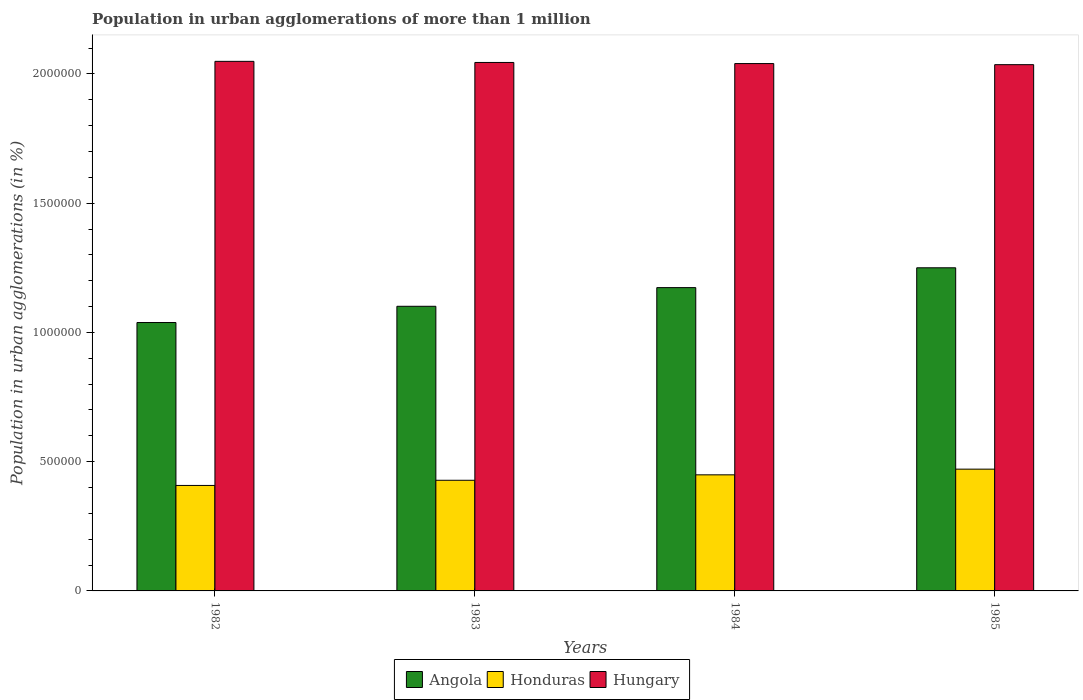How many different coloured bars are there?
Keep it short and to the point. 3. How many groups of bars are there?
Your answer should be very brief. 4. How many bars are there on the 4th tick from the left?
Offer a terse response. 3. How many bars are there on the 1st tick from the right?
Offer a terse response. 3. What is the label of the 3rd group of bars from the left?
Your answer should be very brief. 1984. In how many cases, is the number of bars for a given year not equal to the number of legend labels?
Provide a short and direct response. 0. What is the population in urban agglomerations in Hungary in 1983?
Ensure brevity in your answer.  2.04e+06. Across all years, what is the maximum population in urban agglomerations in Angola?
Provide a succinct answer. 1.25e+06. Across all years, what is the minimum population in urban agglomerations in Angola?
Offer a very short reply. 1.04e+06. In which year was the population in urban agglomerations in Angola maximum?
Provide a short and direct response. 1985. What is the total population in urban agglomerations in Honduras in the graph?
Provide a short and direct response. 1.76e+06. What is the difference between the population in urban agglomerations in Hungary in 1983 and that in 1984?
Offer a terse response. 4282. What is the difference between the population in urban agglomerations in Honduras in 1983 and the population in urban agglomerations in Angola in 1984?
Your answer should be compact. -7.45e+05. What is the average population in urban agglomerations in Angola per year?
Your response must be concise. 1.14e+06. In the year 1982, what is the difference between the population in urban agglomerations in Hungary and population in urban agglomerations in Honduras?
Your response must be concise. 1.64e+06. What is the ratio of the population in urban agglomerations in Hungary in 1983 to that in 1985?
Your answer should be very brief. 1. Is the difference between the population in urban agglomerations in Hungary in 1982 and 1984 greater than the difference between the population in urban agglomerations in Honduras in 1982 and 1984?
Keep it short and to the point. Yes. What is the difference between the highest and the second highest population in urban agglomerations in Hungary?
Your answer should be very brief. 4284. What is the difference between the highest and the lowest population in urban agglomerations in Honduras?
Make the answer very short. 6.31e+04. Is the sum of the population in urban agglomerations in Honduras in 1982 and 1984 greater than the maximum population in urban agglomerations in Angola across all years?
Give a very brief answer. No. What does the 2nd bar from the left in 1985 represents?
Provide a succinct answer. Honduras. What does the 2nd bar from the right in 1984 represents?
Provide a short and direct response. Honduras. Is it the case that in every year, the sum of the population in urban agglomerations in Hungary and population in urban agglomerations in Honduras is greater than the population in urban agglomerations in Angola?
Provide a short and direct response. Yes. How many bars are there?
Provide a short and direct response. 12. How many years are there in the graph?
Your response must be concise. 4. What is the difference between two consecutive major ticks on the Y-axis?
Offer a terse response. 5.00e+05. Are the values on the major ticks of Y-axis written in scientific E-notation?
Provide a succinct answer. No. Does the graph contain any zero values?
Offer a terse response. No. What is the title of the graph?
Provide a succinct answer. Population in urban agglomerations of more than 1 million. Does "Nigeria" appear as one of the legend labels in the graph?
Provide a succinct answer. No. What is the label or title of the Y-axis?
Offer a very short reply. Population in urban agglomerations (in %). What is the Population in urban agglomerations (in %) of Angola in 1982?
Your answer should be very brief. 1.04e+06. What is the Population in urban agglomerations (in %) of Honduras in 1982?
Your answer should be compact. 4.08e+05. What is the Population in urban agglomerations (in %) in Hungary in 1982?
Keep it short and to the point. 2.05e+06. What is the Population in urban agglomerations (in %) of Angola in 1983?
Ensure brevity in your answer.  1.10e+06. What is the Population in urban agglomerations (in %) in Honduras in 1983?
Make the answer very short. 4.28e+05. What is the Population in urban agglomerations (in %) of Hungary in 1983?
Your answer should be compact. 2.04e+06. What is the Population in urban agglomerations (in %) in Angola in 1984?
Give a very brief answer. 1.17e+06. What is the Population in urban agglomerations (in %) of Honduras in 1984?
Provide a short and direct response. 4.49e+05. What is the Population in urban agglomerations (in %) in Hungary in 1984?
Make the answer very short. 2.04e+06. What is the Population in urban agglomerations (in %) of Angola in 1985?
Provide a succinct answer. 1.25e+06. What is the Population in urban agglomerations (in %) in Honduras in 1985?
Your answer should be compact. 4.71e+05. What is the Population in urban agglomerations (in %) of Hungary in 1985?
Make the answer very short. 2.04e+06. Across all years, what is the maximum Population in urban agglomerations (in %) in Angola?
Your answer should be very brief. 1.25e+06. Across all years, what is the maximum Population in urban agglomerations (in %) in Honduras?
Provide a short and direct response. 4.71e+05. Across all years, what is the maximum Population in urban agglomerations (in %) in Hungary?
Ensure brevity in your answer.  2.05e+06. Across all years, what is the minimum Population in urban agglomerations (in %) in Angola?
Provide a short and direct response. 1.04e+06. Across all years, what is the minimum Population in urban agglomerations (in %) of Honduras?
Offer a very short reply. 4.08e+05. Across all years, what is the minimum Population in urban agglomerations (in %) in Hungary?
Ensure brevity in your answer.  2.04e+06. What is the total Population in urban agglomerations (in %) of Angola in the graph?
Offer a very short reply. 4.56e+06. What is the total Population in urban agglomerations (in %) in Honduras in the graph?
Your response must be concise. 1.76e+06. What is the total Population in urban agglomerations (in %) of Hungary in the graph?
Provide a succinct answer. 8.17e+06. What is the difference between the Population in urban agglomerations (in %) of Angola in 1982 and that in 1983?
Provide a succinct answer. -6.28e+04. What is the difference between the Population in urban agglomerations (in %) in Honduras in 1982 and that in 1983?
Provide a succinct answer. -2.00e+04. What is the difference between the Population in urban agglomerations (in %) of Hungary in 1982 and that in 1983?
Make the answer very short. 4284. What is the difference between the Population in urban agglomerations (in %) of Angola in 1982 and that in 1984?
Offer a very short reply. -1.35e+05. What is the difference between the Population in urban agglomerations (in %) in Honduras in 1982 and that in 1984?
Your response must be concise. -4.11e+04. What is the difference between the Population in urban agglomerations (in %) in Hungary in 1982 and that in 1984?
Ensure brevity in your answer.  8566. What is the difference between the Population in urban agglomerations (in %) of Angola in 1982 and that in 1985?
Give a very brief answer. -2.12e+05. What is the difference between the Population in urban agglomerations (in %) in Honduras in 1982 and that in 1985?
Your answer should be compact. -6.31e+04. What is the difference between the Population in urban agglomerations (in %) in Hungary in 1982 and that in 1985?
Make the answer very short. 1.28e+04. What is the difference between the Population in urban agglomerations (in %) of Angola in 1983 and that in 1984?
Offer a very short reply. -7.22e+04. What is the difference between the Population in urban agglomerations (in %) in Honduras in 1983 and that in 1984?
Your answer should be very brief. -2.10e+04. What is the difference between the Population in urban agglomerations (in %) in Hungary in 1983 and that in 1984?
Your answer should be very brief. 4282. What is the difference between the Population in urban agglomerations (in %) in Angola in 1983 and that in 1985?
Give a very brief answer. -1.49e+05. What is the difference between the Population in urban agglomerations (in %) in Honduras in 1983 and that in 1985?
Provide a short and direct response. -4.30e+04. What is the difference between the Population in urban agglomerations (in %) of Hungary in 1983 and that in 1985?
Offer a very short reply. 8542. What is the difference between the Population in urban agglomerations (in %) of Angola in 1984 and that in 1985?
Your answer should be very brief. -7.67e+04. What is the difference between the Population in urban agglomerations (in %) in Honduras in 1984 and that in 1985?
Provide a succinct answer. -2.20e+04. What is the difference between the Population in urban agglomerations (in %) in Hungary in 1984 and that in 1985?
Your answer should be compact. 4260. What is the difference between the Population in urban agglomerations (in %) of Angola in 1982 and the Population in urban agglomerations (in %) of Honduras in 1983?
Your response must be concise. 6.10e+05. What is the difference between the Population in urban agglomerations (in %) of Angola in 1982 and the Population in urban agglomerations (in %) of Hungary in 1983?
Ensure brevity in your answer.  -1.01e+06. What is the difference between the Population in urban agglomerations (in %) in Honduras in 1982 and the Population in urban agglomerations (in %) in Hungary in 1983?
Your answer should be very brief. -1.64e+06. What is the difference between the Population in urban agglomerations (in %) in Angola in 1982 and the Population in urban agglomerations (in %) in Honduras in 1984?
Provide a short and direct response. 5.89e+05. What is the difference between the Population in urban agglomerations (in %) of Angola in 1982 and the Population in urban agglomerations (in %) of Hungary in 1984?
Ensure brevity in your answer.  -1.00e+06. What is the difference between the Population in urban agglomerations (in %) of Honduras in 1982 and the Population in urban agglomerations (in %) of Hungary in 1984?
Your answer should be very brief. -1.63e+06. What is the difference between the Population in urban agglomerations (in %) of Angola in 1982 and the Population in urban agglomerations (in %) of Honduras in 1985?
Offer a terse response. 5.67e+05. What is the difference between the Population in urban agglomerations (in %) in Angola in 1982 and the Population in urban agglomerations (in %) in Hungary in 1985?
Offer a very short reply. -9.97e+05. What is the difference between the Population in urban agglomerations (in %) in Honduras in 1982 and the Population in urban agglomerations (in %) in Hungary in 1985?
Offer a very short reply. -1.63e+06. What is the difference between the Population in urban agglomerations (in %) in Angola in 1983 and the Population in urban agglomerations (in %) in Honduras in 1984?
Your answer should be very brief. 6.52e+05. What is the difference between the Population in urban agglomerations (in %) in Angola in 1983 and the Population in urban agglomerations (in %) in Hungary in 1984?
Keep it short and to the point. -9.39e+05. What is the difference between the Population in urban agglomerations (in %) in Honduras in 1983 and the Population in urban agglomerations (in %) in Hungary in 1984?
Give a very brief answer. -1.61e+06. What is the difference between the Population in urban agglomerations (in %) in Angola in 1983 and the Population in urban agglomerations (in %) in Honduras in 1985?
Your answer should be very brief. 6.30e+05. What is the difference between the Population in urban agglomerations (in %) of Angola in 1983 and the Population in urban agglomerations (in %) of Hungary in 1985?
Offer a very short reply. -9.35e+05. What is the difference between the Population in urban agglomerations (in %) in Honduras in 1983 and the Population in urban agglomerations (in %) in Hungary in 1985?
Provide a short and direct response. -1.61e+06. What is the difference between the Population in urban agglomerations (in %) of Angola in 1984 and the Population in urban agglomerations (in %) of Honduras in 1985?
Offer a very short reply. 7.02e+05. What is the difference between the Population in urban agglomerations (in %) of Angola in 1984 and the Population in urban agglomerations (in %) of Hungary in 1985?
Provide a short and direct response. -8.62e+05. What is the difference between the Population in urban agglomerations (in %) in Honduras in 1984 and the Population in urban agglomerations (in %) in Hungary in 1985?
Your answer should be very brief. -1.59e+06. What is the average Population in urban agglomerations (in %) in Angola per year?
Offer a very short reply. 1.14e+06. What is the average Population in urban agglomerations (in %) in Honduras per year?
Your answer should be compact. 4.39e+05. What is the average Population in urban agglomerations (in %) in Hungary per year?
Provide a short and direct response. 2.04e+06. In the year 1982, what is the difference between the Population in urban agglomerations (in %) of Angola and Population in urban agglomerations (in %) of Honduras?
Keep it short and to the point. 6.30e+05. In the year 1982, what is the difference between the Population in urban agglomerations (in %) in Angola and Population in urban agglomerations (in %) in Hungary?
Ensure brevity in your answer.  -1.01e+06. In the year 1982, what is the difference between the Population in urban agglomerations (in %) of Honduras and Population in urban agglomerations (in %) of Hungary?
Provide a succinct answer. -1.64e+06. In the year 1983, what is the difference between the Population in urban agglomerations (in %) of Angola and Population in urban agglomerations (in %) of Honduras?
Provide a short and direct response. 6.73e+05. In the year 1983, what is the difference between the Population in urban agglomerations (in %) in Angola and Population in urban agglomerations (in %) in Hungary?
Keep it short and to the point. -9.43e+05. In the year 1983, what is the difference between the Population in urban agglomerations (in %) of Honduras and Population in urban agglomerations (in %) of Hungary?
Make the answer very short. -1.62e+06. In the year 1984, what is the difference between the Population in urban agglomerations (in %) in Angola and Population in urban agglomerations (in %) in Honduras?
Keep it short and to the point. 7.24e+05. In the year 1984, what is the difference between the Population in urban agglomerations (in %) in Angola and Population in urban agglomerations (in %) in Hungary?
Your response must be concise. -8.67e+05. In the year 1984, what is the difference between the Population in urban agglomerations (in %) in Honduras and Population in urban agglomerations (in %) in Hungary?
Give a very brief answer. -1.59e+06. In the year 1985, what is the difference between the Population in urban agglomerations (in %) in Angola and Population in urban agglomerations (in %) in Honduras?
Ensure brevity in your answer.  7.79e+05. In the year 1985, what is the difference between the Population in urban agglomerations (in %) of Angola and Population in urban agglomerations (in %) of Hungary?
Make the answer very short. -7.86e+05. In the year 1985, what is the difference between the Population in urban agglomerations (in %) in Honduras and Population in urban agglomerations (in %) in Hungary?
Offer a very short reply. -1.56e+06. What is the ratio of the Population in urban agglomerations (in %) of Angola in 1982 to that in 1983?
Offer a very short reply. 0.94. What is the ratio of the Population in urban agglomerations (in %) in Honduras in 1982 to that in 1983?
Your answer should be compact. 0.95. What is the ratio of the Population in urban agglomerations (in %) in Hungary in 1982 to that in 1983?
Give a very brief answer. 1. What is the ratio of the Population in urban agglomerations (in %) of Angola in 1982 to that in 1984?
Provide a short and direct response. 0.88. What is the ratio of the Population in urban agglomerations (in %) in Honduras in 1982 to that in 1984?
Your answer should be very brief. 0.91. What is the ratio of the Population in urban agglomerations (in %) of Angola in 1982 to that in 1985?
Keep it short and to the point. 0.83. What is the ratio of the Population in urban agglomerations (in %) in Honduras in 1982 to that in 1985?
Offer a very short reply. 0.87. What is the ratio of the Population in urban agglomerations (in %) in Hungary in 1982 to that in 1985?
Ensure brevity in your answer.  1.01. What is the ratio of the Population in urban agglomerations (in %) of Angola in 1983 to that in 1984?
Offer a terse response. 0.94. What is the ratio of the Population in urban agglomerations (in %) of Honduras in 1983 to that in 1984?
Ensure brevity in your answer.  0.95. What is the ratio of the Population in urban agglomerations (in %) of Angola in 1983 to that in 1985?
Provide a short and direct response. 0.88. What is the ratio of the Population in urban agglomerations (in %) of Honduras in 1983 to that in 1985?
Provide a succinct answer. 0.91. What is the ratio of the Population in urban agglomerations (in %) of Angola in 1984 to that in 1985?
Make the answer very short. 0.94. What is the ratio of the Population in urban agglomerations (in %) of Honduras in 1984 to that in 1985?
Keep it short and to the point. 0.95. What is the ratio of the Population in urban agglomerations (in %) in Hungary in 1984 to that in 1985?
Your response must be concise. 1. What is the difference between the highest and the second highest Population in urban agglomerations (in %) of Angola?
Your answer should be very brief. 7.67e+04. What is the difference between the highest and the second highest Population in urban agglomerations (in %) of Honduras?
Ensure brevity in your answer.  2.20e+04. What is the difference between the highest and the second highest Population in urban agglomerations (in %) in Hungary?
Keep it short and to the point. 4284. What is the difference between the highest and the lowest Population in urban agglomerations (in %) in Angola?
Keep it short and to the point. 2.12e+05. What is the difference between the highest and the lowest Population in urban agglomerations (in %) of Honduras?
Keep it short and to the point. 6.31e+04. What is the difference between the highest and the lowest Population in urban agglomerations (in %) of Hungary?
Your response must be concise. 1.28e+04. 